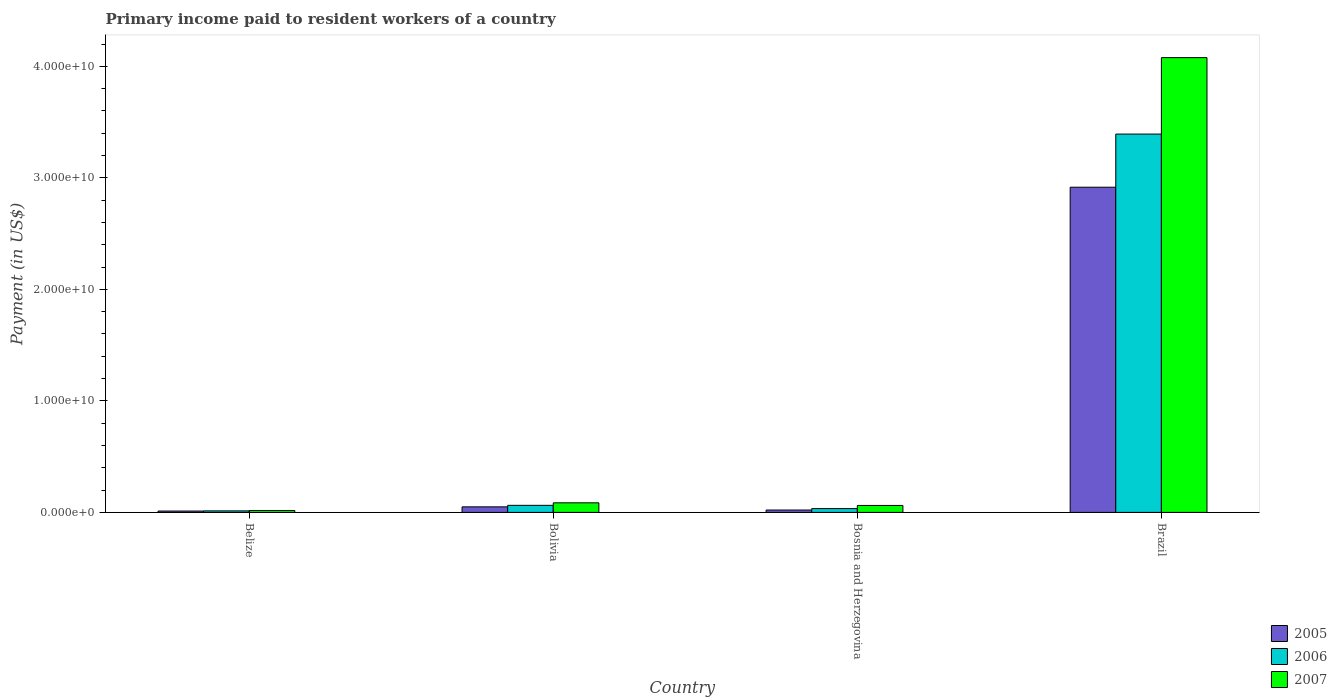Are the number of bars on each tick of the X-axis equal?
Give a very brief answer. Yes. How many bars are there on the 1st tick from the right?
Keep it short and to the point. 3. What is the label of the 4th group of bars from the left?
Offer a very short reply. Brazil. What is the amount paid to workers in 2006 in Bolivia?
Provide a short and direct response. 6.33e+08. Across all countries, what is the maximum amount paid to workers in 2005?
Offer a terse response. 2.92e+1. Across all countries, what is the minimum amount paid to workers in 2007?
Ensure brevity in your answer.  1.66e+08. In which country was the amount paid to workers in 2005 minimum?
Keep it short and to the point. Belize. What is the total amount paid to workers in 2006 in the graph?
Make the answer very short. 3.50e+1. What is the difference between the amount paid to workers in 2005 in Bolivia and that in Bosnia and Herzegovina?
Your answer should be compact. 2.85e+08. What is the difference between the amount paid to workers in 2006 in Brazil and the amount paid to workers in 2005 in Bolivia?
Keep it short and to the point. 3.34e+1. What is the average amount paid to workers in 2005 per country?
Provide a short and direct response. 7.50e+09. What is the difference between the amount paid to workers of/in 2005 and amount paid to workers of/in 2006 in Belize?
Provide a succinct answer. -1.42e+07. What is the ratio of the amount paid to workers in 2006 in Belize to that in Brazil?
Offer a very short reply. 0. Is the amount paid to workers in 2005 in Bolivia less than that in Bosnia and Herzegovina?
Offer a terse response. No. Is the difference between the amount paid to workers in 2005 in Belize and Brazil greater than the difference between the amount paid to workers in 2006 in Belize and Brazil?
Provide a succinct answer. Yes. What is the difference between the highest and the second highest amount paid to workers in 2006?
Your answer should be very brief. -2.93e+08. What is the difference between the highest and the lowest amount paid to workers in 2007?
Offer a very short reply. 4.06e+1. Is the sum of the amount paid to workers in 2006 in Bolivia and Bosnia and Herzegovina greater than the maximum amount paid to workers in 2007 across all countries?
Your answer should be very brief. No. What does the 1st bar from the left in Bosnia and Herzegovina represents?
Offer a very short reply. 2005. What does the 1st bar from the right in Belize represents?
Keep it short and to the point. 2007. Are all the bars in the graph horizontal?
Your answer should be very brief. No. Where does the legend appear in the graph?
Ensure brevity in your answer.  Bottom right. How many legend labels are there?
Offer a terse response. 3. What is the title of the graph?
Provide a succinct answer. Primary income paid to resident workers of a country. Does "1961" appear as one of the legend labels in the graph?
Ensure brevity in your answer.  No. What is the label or title of the Y-axis?
Ensure brevity in your answer.  Payment (in US$). What is the Payment (in US$) of 2005 in Belize?
Keep it short and to the point. 1.21e+08. What is the Payment (in US$) of 2006 in Belize?
Your response must be concise. 1.35e+08. What is the Payment (in US$) in 2007 in Belize?
Ensure brevity in your answer.  1.66e+08. What is the Payment (in US$) of 2005 in Bolivia?
Your response must be concise. 4.98e+08. What is the Payment (in US$) of 2006 in Bolivia?
Your answer should be compact. 6.33e+08. What is the Payment (in US$) of 2007 in Bolivia?
Your answer should be compact. 8.59e+08. What is the Payment (in US$) of 2005 in Bosnia and Herzegovina?
Make the answer very short. 2.13e+08. What is the Payment (in US$) in 2006 in Bosnia and Herzegovina?
Make the answer very short. 3.40e+08. What is the Payment (in US$) of 2007 in Bosnia and Herzegovina?
Your answer should be very brief. 6.23e+08. What is the Payment (in US$) in 2005 in Brazil?
Make the answer very short. 2.92e+1. What is the Payment (in US$) in 2006 in Brazil?
Give a very brief answer. 3.39e+1. What is the Payment (in US$) of 2007 in Brazil?
Ensure brevity in your answer.  4.08e+1. Across all countries, what is the maximum Payment (in US$) in 2005?
Your response must be concise. 2.92e+1. Across all countries, what is the maximum Payment (in US$) of 2006?
Keep it short and to the point. 3.39e+1. Across all countries, what is the maximum Payment (in US$) of 2007?
Your answer should be compact. 4.08e+1. Across all countries, what is the minimum Payment (in US$) of 2005?
Keep it short and to the point. 1.21e+08. Across all countries, what is the minimum Payment (in US$) of 2006?
Provide a short and direct response. 1.35e+08. Across all countries, what is the minimum Payment (in US$) in 2007?
Offer a terse response. 1.66e+08. What is the total Payment (in US$) of 2005 in the graph?
Keep it short and to the point. 3.00e+1. What is the total Payment (in US$) of 2006 in the graph?
Ensure brevity in your answer.  3.50e+1. What is the total Payment (in US$) of 2007 in the graph?
Your answer should be compact. 4.24e+1. What is the difference between the Payment (in US$) in 2005 in Belize and that in Bolivia?
Make the answer very short. -3.76e+08. What is the difference between the Payment (in US$) in 2006 in Belize and that in Bolivia?
Your answer should be very brief. -4.97e+08. What is the difference between the Payment (in US$) of 2007 in Belize and that in Bolivia?
Make the answer very short. -6.93e+08. What is the difference between the Payment (in US$) of 2005 in Belize and that in Bosnia and Herzegovina?
Ensure brevity in your answer.  -9.16e+07. What is the difference between the Payment (in US$) in 2006 in Belize and that in Bosnia and Herzegovina?
Your response must be concise. -2.05e+08. What is the difference between the Payment (in US$) of 2007 in Belize and that in Bosnia and Herzegovina?
Provide a short and direct response. -4.57e+08. What is the difference between the Payment (in US$) in 2005 in Belize and that in Brazil?
Your answer should be compact. -2.90e+1. What is the difference between the Payment (in US$) in 2006 in Belize and that in Brazil?
Offer a terse response. -3.38e+1. What is the difference between the Payment (in US$) in 2007 in Belize and that in Brazil?
Your answer should be compact. -4.06e+1. What is the difference between the Payment (in US$) in 2005 in Bolivia and that in Bosnia and Herzegovina?
Make the answer very short. 2.85e+08. What is the difference between the Payment (in US$) of 2006 in Bolivia and that in Bosnia and Herzegovina?
Keep it short and to the point. 2.93e+08. What is the difference between the Payment (in US$) in 2007 in Bolivia and that in Bosnia and Herzegovina?
Offer a terse response. 2.36e+08. What is the difference between the Payment (in US$) of 2005 in Bolivia and that in Brazil?
Offer a very short reply. -2.87e+1. What is the difference between the Payment (in US$) in 2006 in Bolivia and that in Brazil?
Your response must be concise. -3.33e+1. What is the difference between the Payment (in US$) of 2007 in Bolivia and that in Brazil?
Ensure brevity in your answer.  -3.99e+1. What is the difference between the Payment (in US$) of 2005 in Bosnia and Herzegovina and that in Brazil?
Ensure brevity in your answer.  -2.89e+1. What is the difference between the Payment (in US$) of 2006 in Bosnia and Herzegovina and that in Brazil?
Your answer should be very brief. -3.36e+1. What is the difference between the Payment (in US$) in 2007 in Bosnia and Herzegovina and that in Brazil?
Your answer should be very brief. -4.02e+1. What is the difference between the Payment (in US$) in 2005 in Belize and the Payment (in US$) in 2006 in Bolivia?
Make the answer very short. -5.11e+08. What is the difference between the Payment (in US$) in 2005 in Belize and the Payment (in US$) in 2007 in Bolivia?
Your answer should be compact. -7.38e+08. What is the difference between the Payment (in US$) in 2006 in Belize and the Payment (in US$) in 2007 in Bolivia?
Offer a terse response. -7.24e+08. What is the difference between the Payment (in US$) in 2005 in Belize and the Payment (in US$) in 2006 in Bosnia and Herzegovina?
Your answer should be compact. -2.19e+08. What is the difference between the Payment (in US$) of 2005 in Belize and the Payment (in US$) of 2007 in Bosnia and Herzegovina?
Your response must be concise. -5.02e+08. What is the difference between the Payment (in US$) in 2006 in Belize and the Payment (in US$) in 2007 in Bosnia and Herzegovina?
Provide a succinct answer. -4.88e+08. What is the difference between the Payment (in US$) of 2005 in Belize and the Payment (in US$) of 2006 in Brazil?
Keep it short and to the point. -3.38e+1. What is the difference between the Payment (in US$) of 2005 in Belize and the Payment (in US$) of 2007 in Brazil?
Provide a short and direct response. -4.07e+1. What is the difference between the Payment (in US$) of 2006 in Belize and the Payment (in US$) of 2007 in Brazil?
Your answer should be very brief. -4.06e+1. What is the difference between the Payment (in US$) in 2005 in Bolivia and the Payment (in US$) in 2006 in Bosnia and Herzegovina?
Your response must be concise. 1.58e+08. What is the difference between the Payment (in US$) in 2005 in Bolivia and the Payment (in US$) in 2007 in Bosnia and Herzegovina?
Make the answer very short. -1.26e+08. What is the difference between the Payment (in US$) in 2006 in Bolivia and the Payment (in US$) in 2007 in Bosnia and Herzegovina?
Give a very brief answer. 9.48e+06. What is the difference between the Payment (in US$) of 2005 in Bolivia and the Payment (in US$) of 2006 in Brazil?
Your answer should be compact. -3.34e+1. What is the difference between the Payment (in US$) in 2005 in Bolivia and the Payment (in US$) in 2007 in Brazil?
Your response must be concise. -4.03e+1. What is the difference between the Payment (in US$) of 2006 in Bolivia and the Payment (in US$) of 2007 in Brazil?
Provide a short and direct response. -4.02e+1. What is the difference between the Payment (in US$) in 2005 in Bosnia and Herzegovina and the Payment (in US$) in 2006 in Brazil?
Offer a terse response. -3.37e+1. What is the difference between the Payment (in US$) in 2005 in Bosnia and Herzegovina and the Payment (in US$) in 2007 in Brazil?
Offer a terse response. -4.06e+1. What is the difference between the Payment (in US$) in 2006 in Bosnia and Herzegovina and the Payment (in US$) in 2007 in Brazil?
Offer a terse response. -4.04e+1. What is the average Payment (in US$) in 2005 per country?
Offer a terse response. 7.50e+09. What is the average Payment (in US$) in 2006 per country?
Your answer should be compact. 8.76e+09. What is the average Payment (in US$) of 2007 per country?
Your answer should be very brief. 1.06e+1. What is the difference between the Payment (in US$) in 2005 and Payment (in US$) in 2006 in Belize?
Provide a succinct answer. -1.42e+07. What is the difference between the Payment (in US$) in 2005 and Payment (in US$) in 2007 in Belize?
Provide a succinct answer. -4.47e+07. What is the difference between the Payment (in US$) in 2006 and Payment (in US$) in 2007 in Belize?
Your response must be concise. -3.05e+07. What is the difference between the Payment (in US$) of 2005 and Payment (in US$) of 2006 in Bolivia?
Your answer should be compact. -1.35e+08. What is the difference between the Payment (in US$) of 2005 and Payment (in US$) of 2007 in Bolivia?
Your answer should be very brief. -3.62e+08. What is the difference between the Payment (in US$) in 2006 and Payment (in US$) in 2007 in Bolivia?
Provide a short and direct response. -2.27e+08. What is the difference between the Payment (in US$) in 2005 and Payment (in US$) in 2006 in Bosnia and Herzegovina?
Your response must be concise. -1.27e+08. What is the difference between the Payment (in US$) of 2005 and Payment (in US$) of 2007 in Bosnia and Herzegovina?
Give a very brief answer. -4.10e+08. What is the difference between the Payment (in US$) of 2006 and Payment (in US$) of 2007 in Bosnia and Herzegovina?
Keep it short and to the point. -2.83e+08. What is the difference between the Payment (in US$) of 2005 and Payment (in US$) of 2006 in Brazil?
Keep it short and to the point. -4.77e+09. What is the difference between the Payment (in US$) of 2005 and Payment (in US$) of 2007 in Brazil?
Your response must be concise. -1.16e+1. What is the difference between the Payment (in US$) in 2006 and Payment (in US$) in 2007 in Brazil?
Provide a succinct answer. -6.86e+09. What is the ratio of the Payment (in US$) of 2005 in Belize to that in Bolivia?
Provide a short and direct response. 0.24. What is the ratio of the Payment (in US$) in 2006 in Belize to that in Bolivia?
Keep it short and to the point. 0.21. What is the ratio of the Payment (in US$) in 2007 in Belize to that in Bolivia?
Your answer should be very brief. 0.19. What is the ratio of the Payment (in US$) in 2005 in Belize to that in Bosnia and Herzegovina?
Provide a succinct answer. 0.57. What is the ratio of the Payment (in US$) of 2006 in Belize to that in Bosnia and Herzegovina?
Provide a short and direct response. 0.4. What is the ratio of the Payment (in US$) of 2007 in Belize to that in Bosnia and Herzegovina?
Your answer should be very brief. 0.27. What is the ratio of the Payment (in US$) of 2005 in Belize to that in Brazil?
Provide a succinct answer. 0. What is the ratio of the Payment (in US$) of 2006 in Belize to that in Brazil?
Offer a terse response. 0. What is the ratio of the Payment (in US$) in 2007 in Belize to that in Brazil?
Provide a short and direct response. 0. What is the ratio of the Payment (in US$) of 2005 in Bolivia to that in Bosnia and Herzegovina?
Your answer should be compact. 2.34. What is the ratio of the Payment (in US$) of 2006 in Bolivia to that in Bosnia and Herzegovina?
Provide a succinct answer. 1.86. What is the ratio of the Payment (in US$) in 2007 in Bolivia to that in Bosnia and Herzegovina?
Provide a succinct answer. 1.38. What is the ratio of the Payment (in US$) of 2005 in Bolivia to that in Brazil?
Provide a succinct answer. 0.02. What is the ratio of the Payment (in US$) in 2006 in Bolivia to that in Brazil?
Your response must be concise. 0.02. What is the ratio of the Payment (in US$) in 2007 in Bolivia to that in Brazil?
Offer a terse response. 0.02. What is the ratio of the Payment (in US$) of 2005 in Bosnia and Herzegovina to that in Brazil?
Keep it short and to the point. 0.01. What is the ratio of the Payment (in US$) in 2006 in Bosnia and Herzegovina to that in Brazil?
Give a very brief answer. 0.01. What is the ratio of the Payment (in US$) of 2007 in Bosnia and Herzegovina to that in Brazil?
Offer a terse response. 0.02. What is the difference between the highest and the second highest Payment (in US$) of 2005?
Your answer should be very brief. 2.87e+1. What is the difference between the highest and the second highest Payment (in US$) in 2006?
Offer a very short reply. 3.33e+1. What is the difference between the highest and the second highest Payment (in US$) of 2007?
Offer a very short reply. 3.99e+1. What is the difference between the highest and the lowest Payment (in US$) in 2005?
Give a very brief answer. 2.90e+1. What is the difference between the highest and the lowest Payment (in US$) of 2006?
Your answer should be very brief. 3.38e+1. What is the difference between the highest and the lowest Payment (in US$) of 2007?
Give a very brief answer. 4.06e+1. 